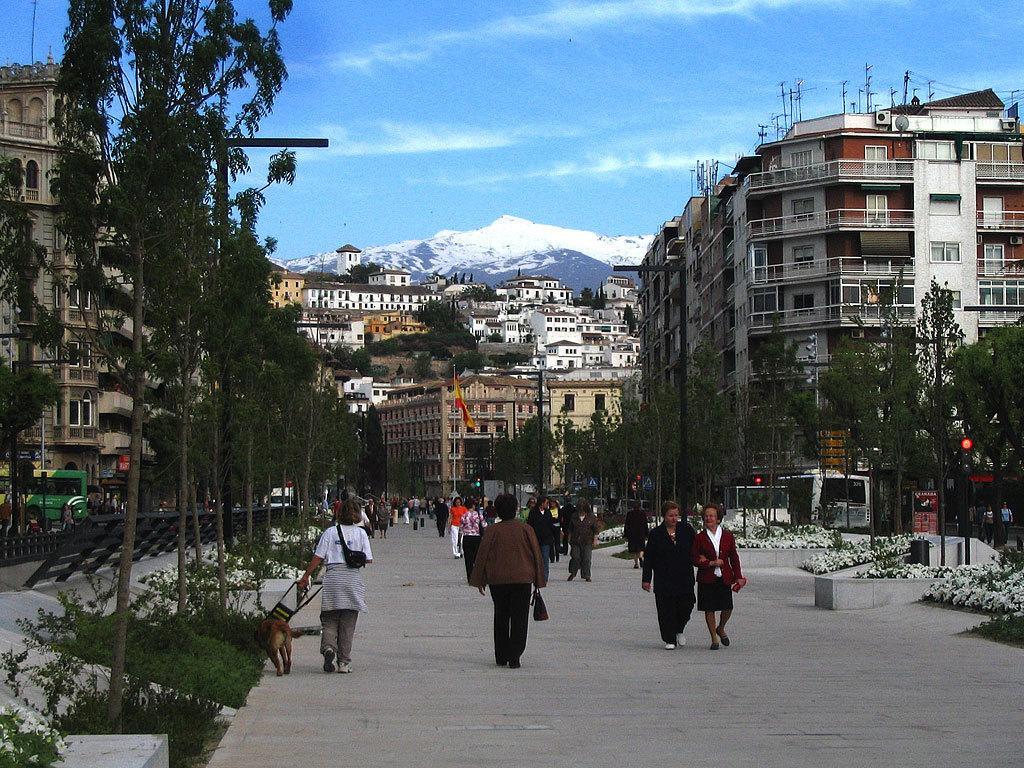Can you describe this image briefly? This is the picture of a city. In this image there are group of people walking on the road and there is a dog walking on the road. There are buildings, trees, poles and there is a flag. At the back there is a mountain and there is a snow on the mountain. At the bottom there is a road and there are flowers and plants. At the top there is sky. 